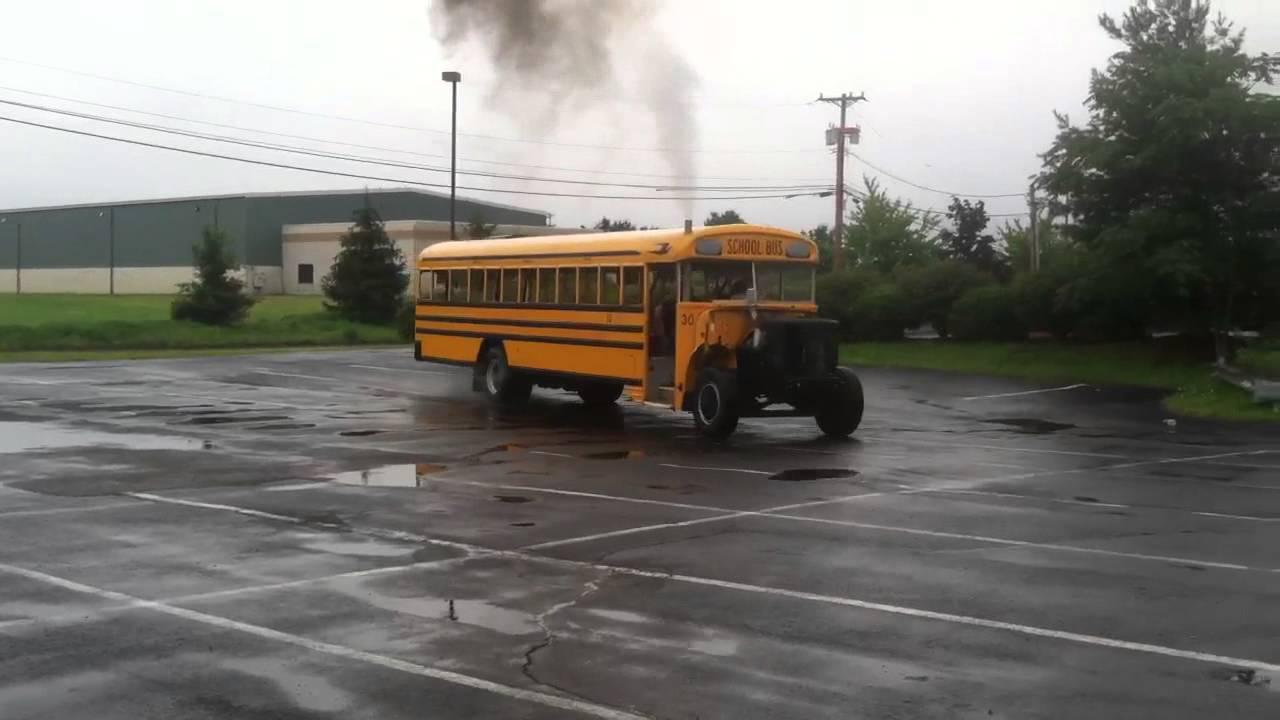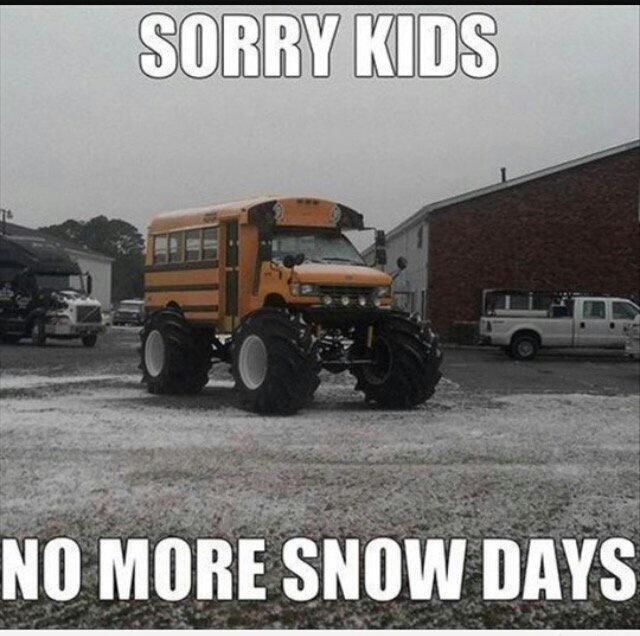The first image is the image on the left, the second image is the image on the right. For the images displayed, is the sentence "The left and right image contains the same number of buses." factually correct? Answer yes or no. Yes. 